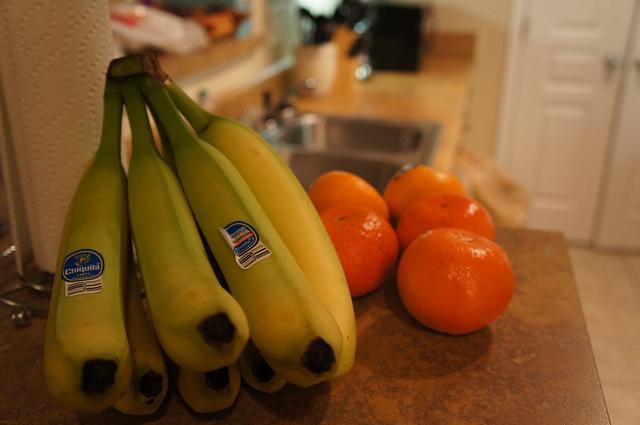How many bananas are there?
Give a very brief answer. 7. How many dining tables are in the photo?
Give a very brief answer. 1. How many oranges are in the picture?
Give a very brief answer. 5. 